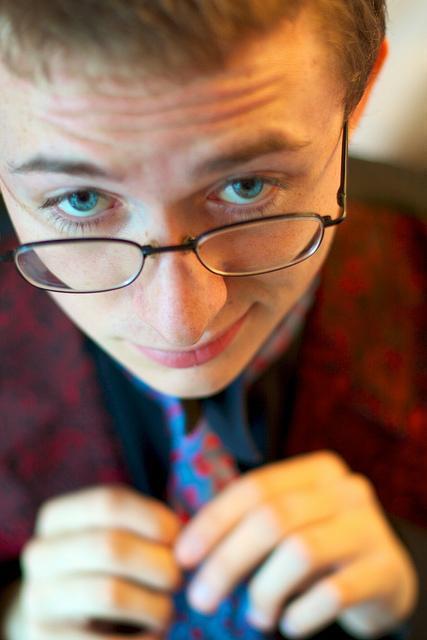How many cows have their tongue sticking out?
Give a very brief answer. 0. 